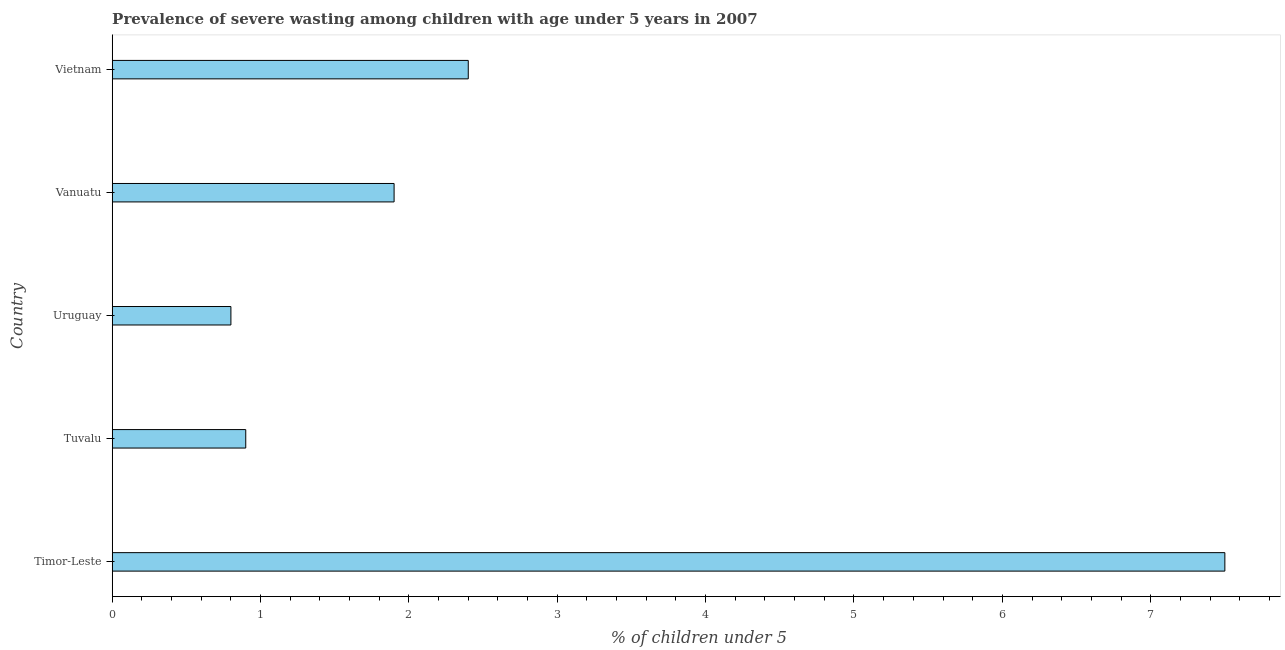What is the title of the graph?
Make the answer very short. Prevalence of severe wasting among children with age under 5 years in 2007. What is the label or title of the X-axis?
Give a very brief answer.  % of children under 5. What is the label or title of the Y-axis?
Ensure brevity in your answer.  Country. What is the prevalence of severe wasting in Vanuatu?
Your response must be concise. 1.9. Across all countries, what is the minimum prevalence of severe wasting?
Keep it short and to the point. 0.8. In which country was the prevalence of severe wasting maximum?
Make the answer very short. Timor-Leste. In which country was the prevalence of severe wasting minimum?
Provide a short and direct response. Uruguay. What is the sum of the prevalence of severe wasting?
Keep it short and to the point. 13.5. What is the average prevalence of severe wasting per country?
Offer a very short reply. 2.7. What is the median prevalence of severe wasting?
Make the answer very short. 1.9. In how many countries, is the prevalence of severe wasting greater than 5 %?
Offer a terse response. 1. What is the ratio of the prevalence of severe wasting in Timor-Leste to that in Vietnam?
Your response must be concise. 3.12. Is the prevalence of severe wasting in Timor-Leste less than that in Vanuatu?
Provide a short and direct response. No. Is the difference between the prevalence of severe wasting in Tuvalu and Uruguay greater than the difference between any two countries?
Offer a very short reply. No. What is the difference between the highest and the lowest prevalence of severe wasting?
Your answer should be very brief. 6.7. In how many countries, is the prevalence of severe wasting greater than the average prevalence of severe wasting taken over all countries?
Give a very brief answer. 1. How many countries are there in the graph?
Ensure brevity in your answer.  5. What is the difference between two consecutive major ticks on the X-axis?
Your response must be concise. 1. What is the  % of children under 5 in Tuvalu?
Provide a short and direct response. 0.9. What is the  % of children under 5 of Uruguay?
Your response must be concise. 0.8. What is the  % of children under 5 in Vanuatu?
Your answer should be very brief. 1.9. What is the  % of children under 5 in Vietnam?
Keep it short and to the point. 2.4. What is the difference between the  % of children under 5 in Timor-Leste and Vanuatu?
Your answer should be compact. 5.6. What is the difference between the  % of children under 5 in Tuvalu and Vanuatu?
Provide a short and direct response. -1. What is the difference between the  % of children under 5 in Uruguay and Vietnam?
Ensure brevity in your answer.  -1.6. What is the difference between the  % of children under 5 in Vanuatu and Vietnam?
Provide a short and direct response. -0.5. What is the ratio of the  % of children under 5 in Timor-Leste to that in Tuvalu?
Offer a very short reply. 8.33. What is the ratio of the  % of children under 5 in Timor-Leste to that in Uruguay?
Give a very brief answer. 9.38. What is the ratio of the  % of children under 5 in Timor-Leste to that in Vanuatu?
Ensure brevity in your answer.  3.95. What is the ratio of the  % of children under 5 in Timor-Leste to that in Vietnam?
Offer a very short reply. 3.12. What is the ratio of the  % of children under 5 in Tuvalu to that in Vanuatu?
Your answer should be very brief. 0.47. What is the ratio of the  % of children under 5 in Uruguay to that in Vanuatu?
Your answer should be compact. 0.42. What is the ratio of the  % of children under 5 in Uruguay to that in Vietnam?
Provide a succinct answer. 0.33. What is the ratio of the  % of children under 5 in Vanuatu to that in Vietnam?
Ensure brevity in your answer.  0.79. 